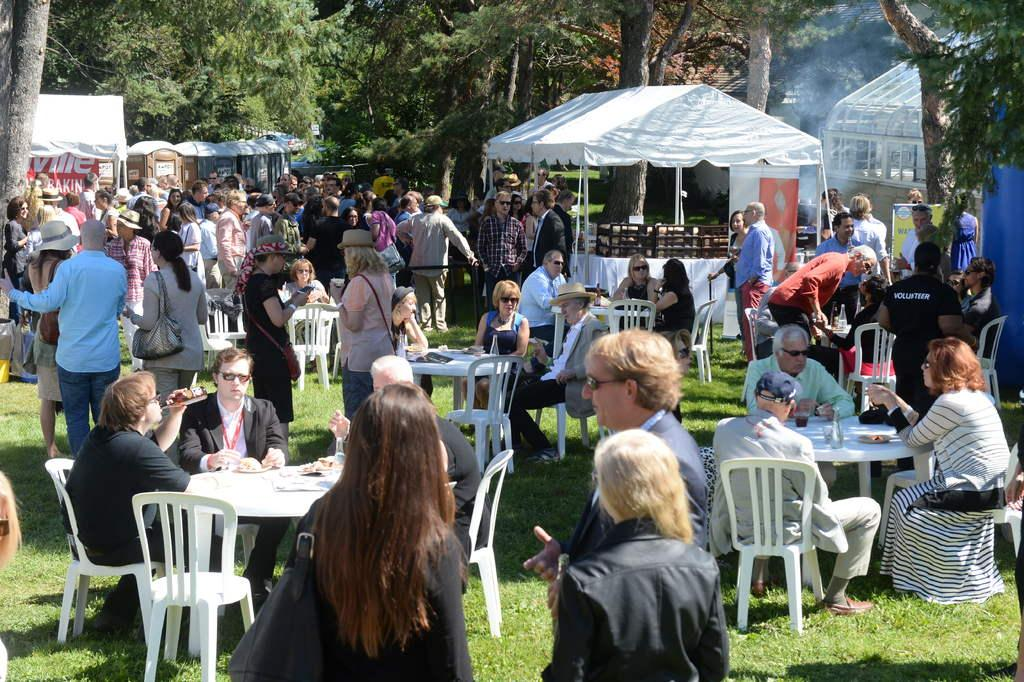How many types of seating are visible in the image? There are chairs, tables, and stools visible in the image. What are the people in the image doing? Some people are standing, and some are sitting. What type of vegetation can be seen in the image? There are trees in the image. What channel is the TV tuned to in the image? There is no TV present in the image, so it is not possible to determine the channel. How many eggs are on the table in the image? There are no eggs visible in the image. 